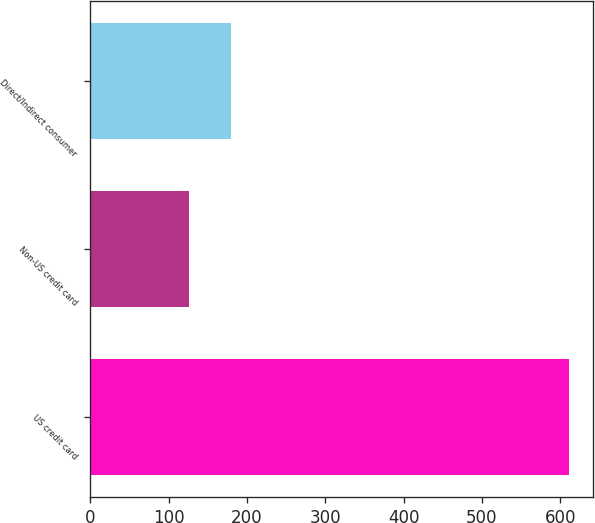Convert chart to OTSL. <chart><loc_0><loc_0><loc_500><loc_500><bar_chart><fcel>US credit card<fcel>Non-US credit card<fcel>Direct/Indirect consumer<nl><fcel>611<fcel>126<fcel>180<nl></chart> 